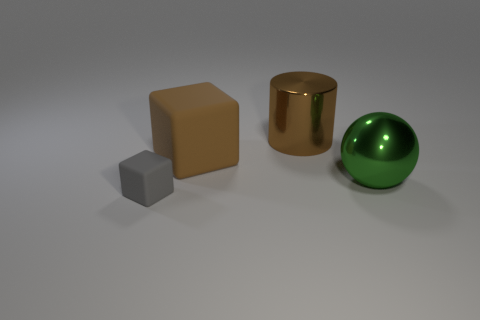Add 2 big brown rubber things. How many objects exist? 6 Add 3 brown objects. How many brown objects are left? 5 Add 4 large green things. How many large green things exist? 5 Subtract 1 gray cubes. How many objects are left? 3 Subtract all small gray spheres. Subtract all large cubes. How many objects are left? 3 